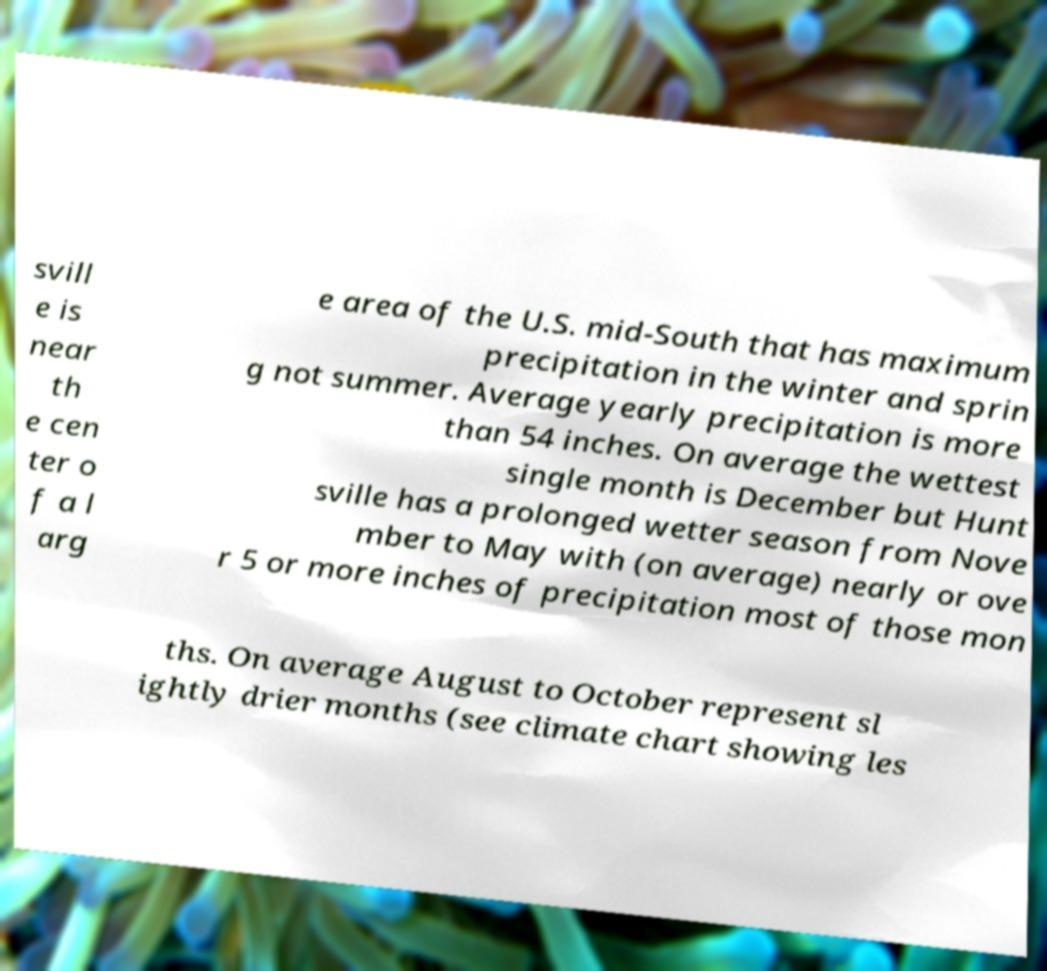Could you assist in decoding the text presented in this image and type it out clearly? svill e is near th e cen ter o f a l arg e area of the U.S. mid-South that has maximum precipitation in the winter and sprin g not summer. Average yearly precipitation is more than 54 inches. On average the wettest single month is December but Hunt sville has a prolonged wetter season from Nove mber to May with (on average) nearly or ove r 5 or more inches of precipitation most of those mon ths. On average August to October represent sl ightly drier months (see climate chart showing les 